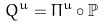Convert formula to latex. <formula><loc_0><loc_0><loc_500><loc_500>Q ^ { u } = \Pi ^ { u } \circ \mathbb { P }</formula> 